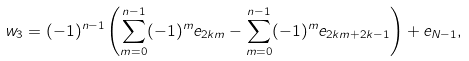Convert formula to latex. <formula><loc_0><loc_0><loc_500><loc_500>w _ { 3 } = ( - 1 ) ^ { n - 1 } \left ( \sum _ { m = 0 } ^ { n - 1 } ( - 1 ) ^ { m } e _ { 2 k m } - \sum _ { m = 0 } ^ { n - 1 } ( - 1 ) ^ { m } e _ { 2 k m + 2 k - 1 } \right ) + e _ { N - 1 } ,</formula> 